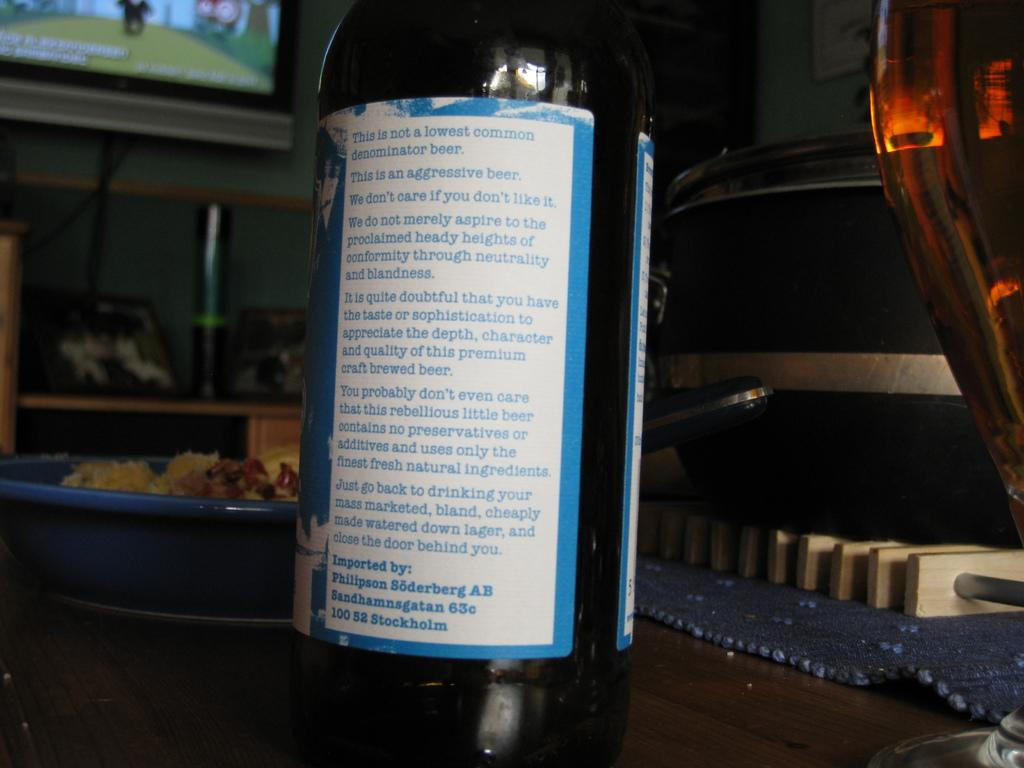<image>
Provide a brief description of the given image. The back label of a bottle that gives detail about the beer. 